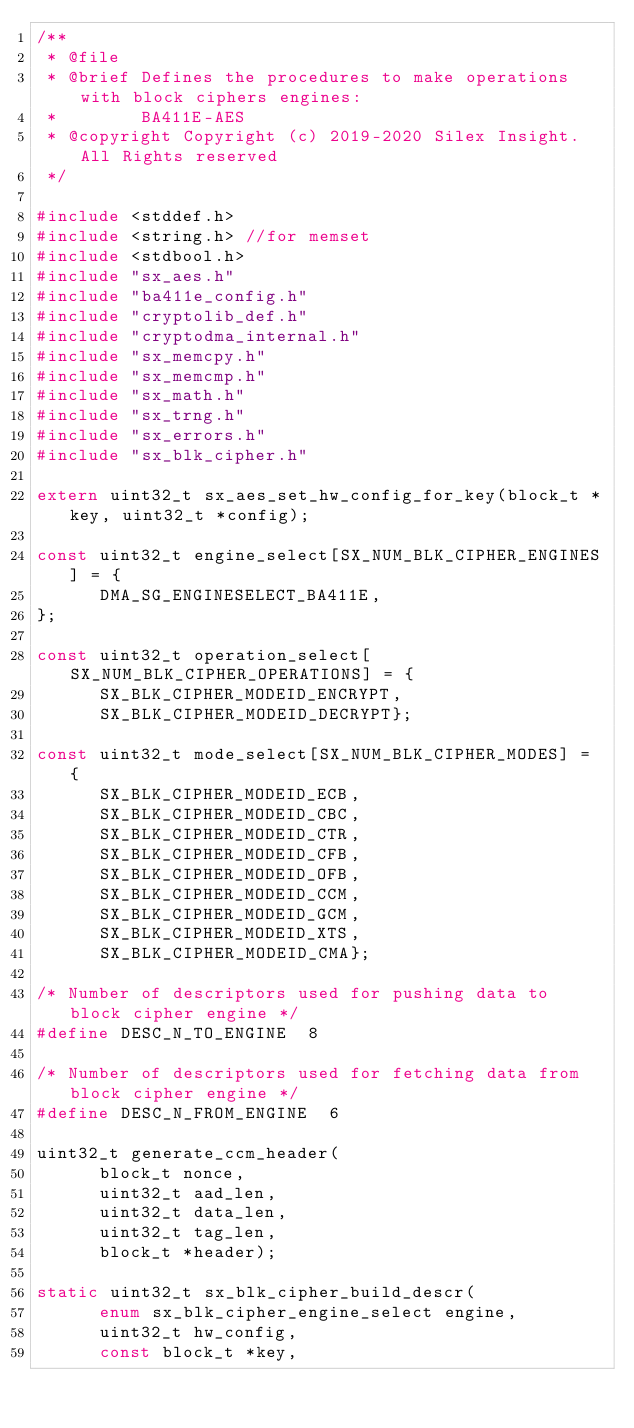<code> <loc_0><loc_0><loc_500><loc_500><_C_>/**
 * @file
 * @brief Defines the procedures to make operations with block ciphers engines:
 *        BA411E-AES
 * @copyright Copyright (c) 2019-2020 Silex Insight. All Rights reserved
 */

#include <stddef.h>
#include <string.h> //for memset
#include <stdbool.h>
#include "sx_aes.h"
#include "ba411e_config.h"
#include "cryptolib_def.h"
#include "cryptodma_internal.h"
#include "sx_memcpy.h"
#include "sx_memcmp.h"
#include "sx_math.h"
#include "sx_trng.h"
#include "sx_errors.h"
#include "sx_blk_cipher.h"

extern uint32_t sx_aes_set_hw_config_for_key(block_t *key, uint32_t *config);

const uint32_t engine_select[SX_NUM_BLK_CIPHER_ENGINES] = {
      DMA_SG_ENGINESELECT_BA411E,
};

const uint32_t operation_select[SX_NUM_BLK_CIPHER_OPERATIONS] = {
      SX_BLK_CIPHER_MODEID_ENCRYPT,
      SX_BLK_CIPHER_MODEID_DECRYPT};

const uint32_t mode_select[SX_NUM_BLK_CIPHER_MODES] = {
      SX_BLK_CIPHER_MODEID_ECB,
      SX_BLK_CIPHER_MODEID_CBC,
      SX_BLK_CIPHER_MODEID_CTR,
      SX_BLK_CIPHER_MODEID_CFB,
      SX_BLK_CIPHER_MODEID_OFB,
      SX_BLK_CIPHER_MODEID_CCM,
      SX_BLK_CIPHER_MODEID_GCM,
      SX_BLK_CIPHER_MODEID_XTS,
      SX_BLK_CIPHER_MODEID_CMA};

/* Number of descriptors used for pushing data to block cipher engine */
#define DESC_N_TO_ENGINE  8

/* Number of descriptors used for fetching data from block cipher engine */
#define DESC_N_FROM_ENGINE  6

uint32_t generate_ccm_header(
      block_t nonce,
      uint32_t aad_len,
      uint32_t data_len,
      uint32_t tag_len,
      block_t *header);

static uint32_t sx_blk_cipher_build_descr(
      enum sx_blk_cipher_engine_select engine,
      uint32_t hw_config,
      const block_t *key,</code> 